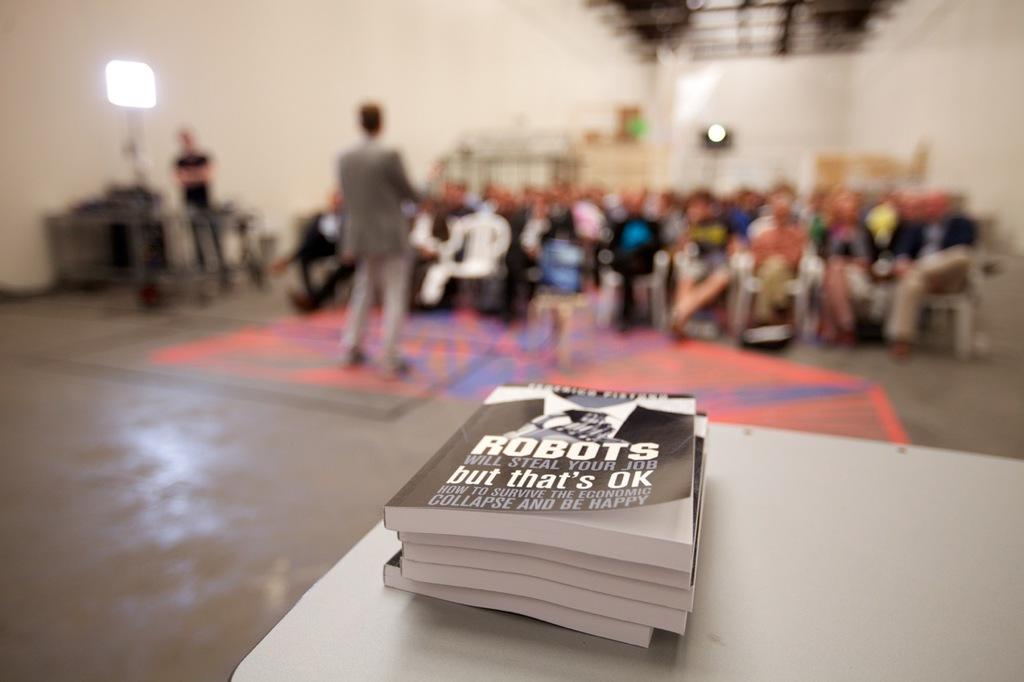Who will steal your job?
Your answer should be very brief. Robots. What is the big bold word on the book?
Give a very brief answer. Robots. 